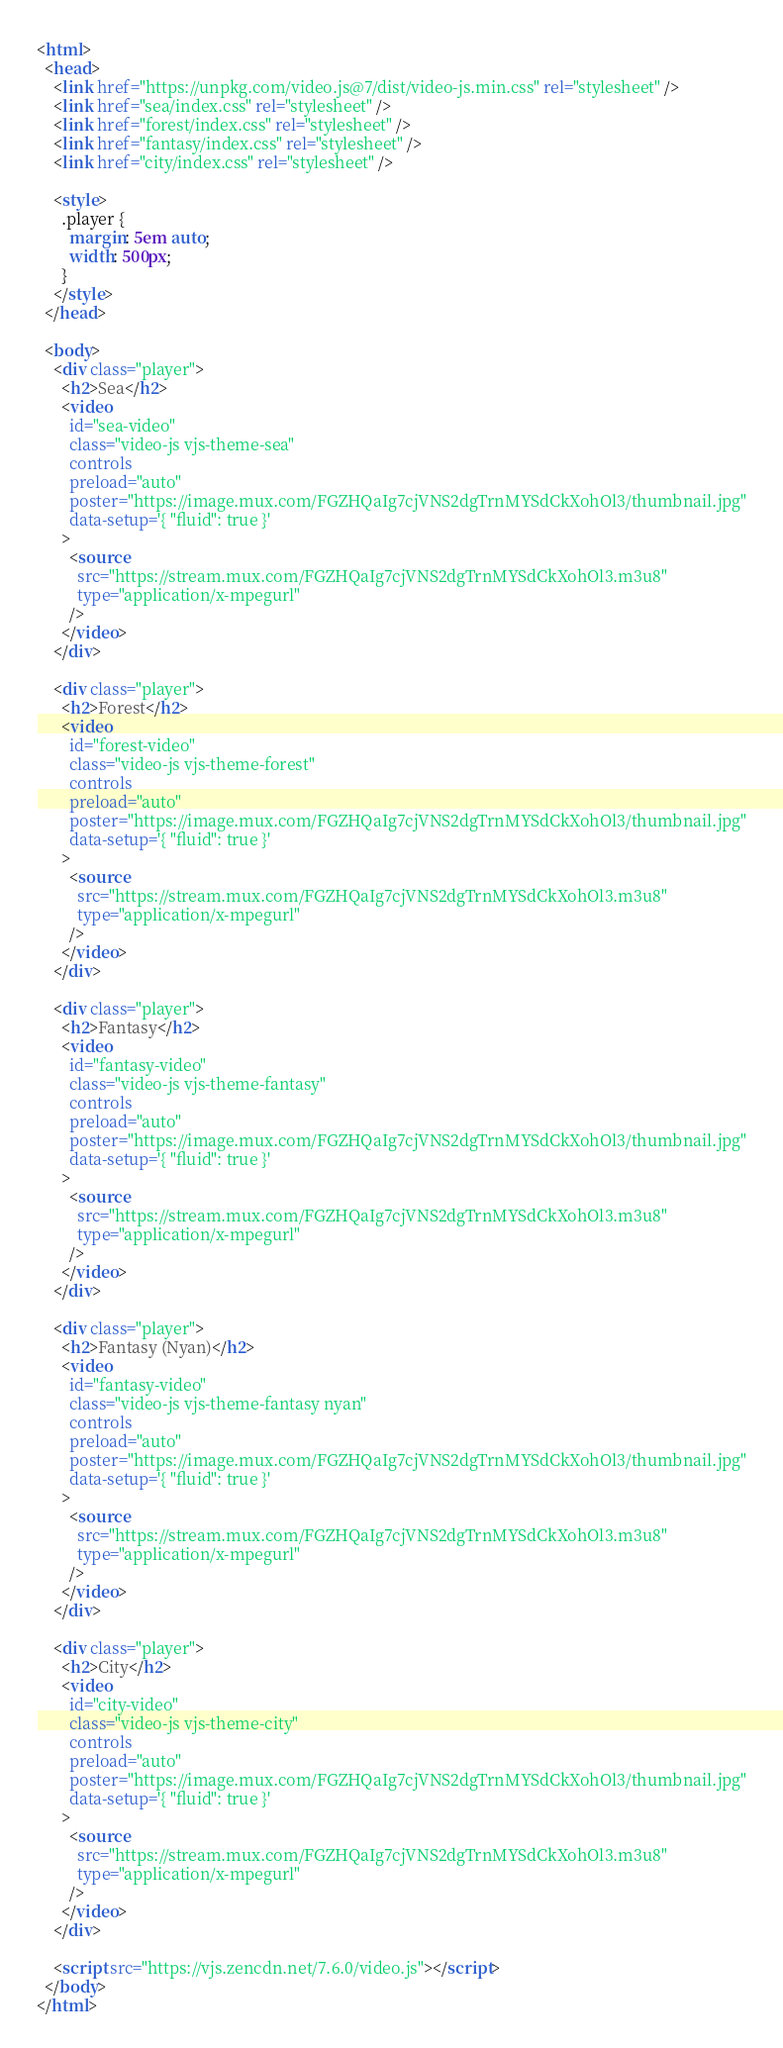Convert code to text. <code><loc_0><loc_0><loc_500><loc_500><_HTML_><html>
  <head>
    <link href="https://unpkg.com/video.js@7/dist/video-js.min.css" rel="stylesheet" />
    <link href="sea/index.css" rel="stylesheet" />
    <link href="forest/index.css" rel="stylesheet" />
    <link href="fantasy/index.css" rel="stylesheet" />
    <link href="city/index.css" rel="stylesheet" />

    <style>
      .player {
        margin: 5em auto;
        width: 500px;
      }
    </style>
  </head>

  <body>
    <div class="player">
      <h2>Sea</h2>
      <video
        id="sea-video"
        class="video-js vjs-theme-sea"
        controls
        preload="auto"
        poster="https://image.mux.com/FGZHQaIg7cjVNS2dgTrnMYSdCkXohOl3/thumbnail.jpg"
        data-setup='{ "fluid": true }'
      >
        <source
          src="https://stream.mux.com/FGZHQaIg7cjVNS2dgTrnMYSdCkXohOl3.m3u8"
          type="application/x-mpegurl"
        />
      </video>
    </div>

    <div class="player">
      <h2>Forest</h2>
      <video
        id="forest-video"
        class="video-js vjs-theme-forest"
        controls
        preload="auto"
        poster="https://image.mux.com/FGZHQaIg7cjVNS2dgTrnMYSdCkXohOl3/thumbnail.jpg"
        data-setup='{ "fluid": true }'
      >
        <source
          src="https://stream.mux.com/FGZHQaIg7cjVNS2dgTrnMYSdCkXohOl3.m3u8"
          type="application/x-mpegurl"
        />
      </video>
    </div>

    <div class="player">
      <h2>Fantasy</h2>
      <video
        id="fantasy-video"
        class="video-js vjs-theme-fantasy"
        controls
        preload="auto"
        poster="https://image.mux.com/FGZHQaIg7cjVNS2dgTrnMYSdCkXohOl3/thumbnail.jpg"
        data-setup='{ "fluid": true }'
      >
        <source
          src="https://stream.mux.com/FGZHQaIg7cjVNS2dgTrnMYSdCkXohOl3.m3u8"
          type="application/x-mpegurl"
        />
      </video>
    </div>

    <div class="player">
      <h2>Fantasy (Nyan)</h2>
      <video
        id="fantasy-video"
        class="video-js vjs-theme-fantasy nyan"
        controls
        preload="auto"
        poster="https://image.mux.com/FGZHQaIg7cjVNS2dgTrnMYSdCkXohOl3/thumbnail.jpg"
        data-setup='{ "fluid": true }'
      >
        <source
          src="https://stream.mux.com/FGZHQaIg7cjVNS2dgTrnMYSdCkXohOl3.m3u8"
          type="application/x-mpegurl"
        />
      </video>
    </div>

    <div class="player">
      <h2>City</h2>
      <video
        id="city-video"
        class="video-js vjs-theme-city"
        controls
        preload="auto"
        poster="https://image.mux.com/FGZHQaIg7cjVNS2dgTrnMYSdCkXohOl3/thumbnail.jpg"
        data-setup='{ "fluid": true }'
      >
        <source
          src="https://stream.mux.com/FGZHQaIg7cjVNS2dgTrnMYSdCkXohOl3.m3u8"
          type="application/x-mpegurl"
        />
      </video>
    </div>

    <script src="https://vjs.zencdn.net/7.6.0/video.js"></script>
  </body>
</html>
</code> 